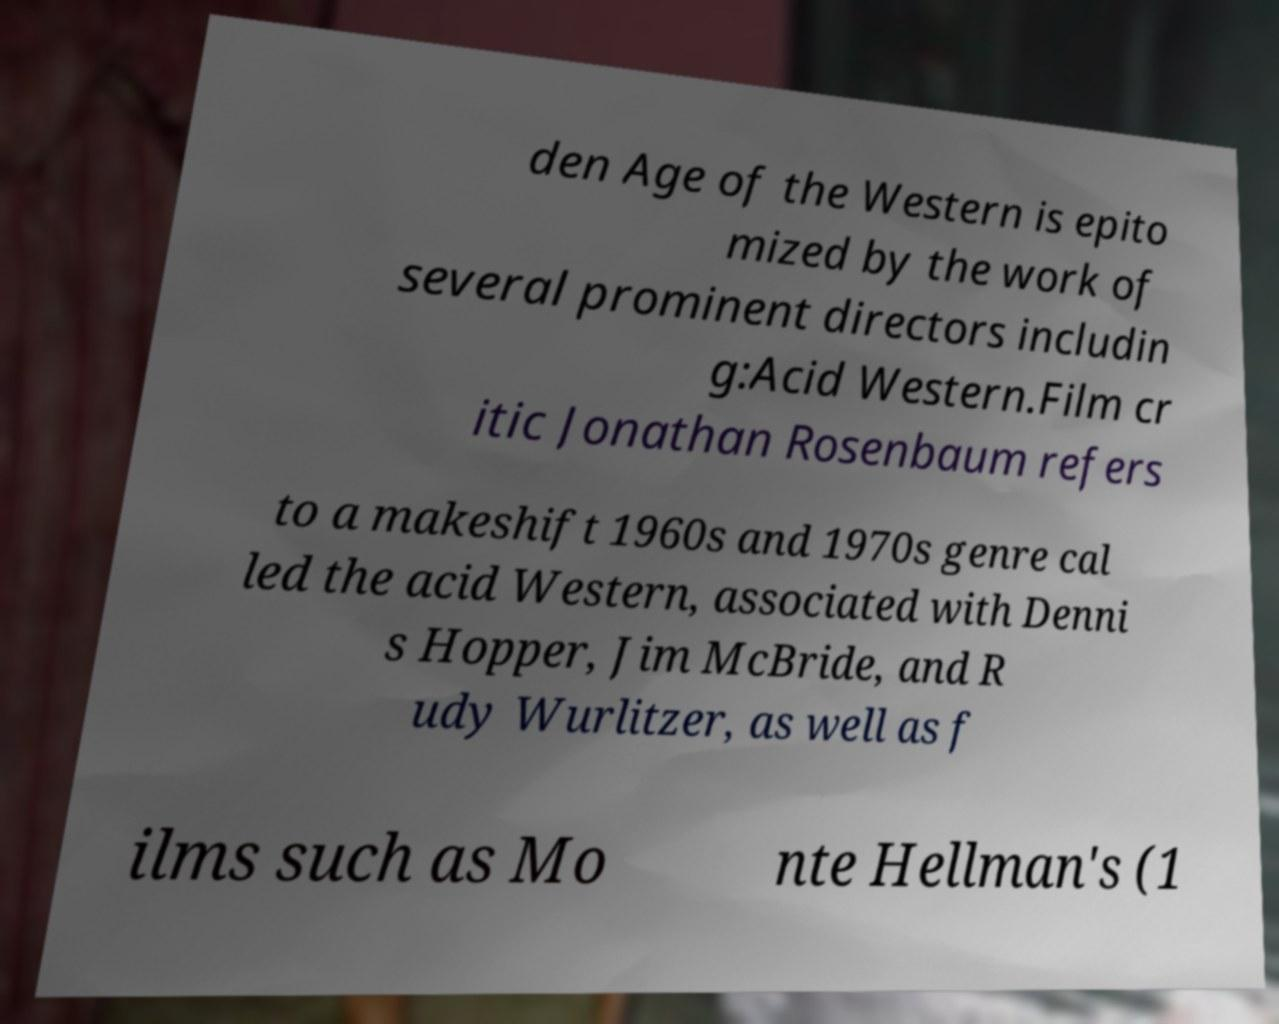Could you extract and type out the text from this image? den Age of the Western is epito mized by the work of several prominent directors includin g:Acid Western.Film cr itic Jonathan Rosenbaum refers to a makeshift 1960s and 1970s genre cal led the acid Western, associated with Denni s Hopper, Jim McBride, and R udy Wurlitzer, as well as f ilms such as Mo nte Hellman's (1 